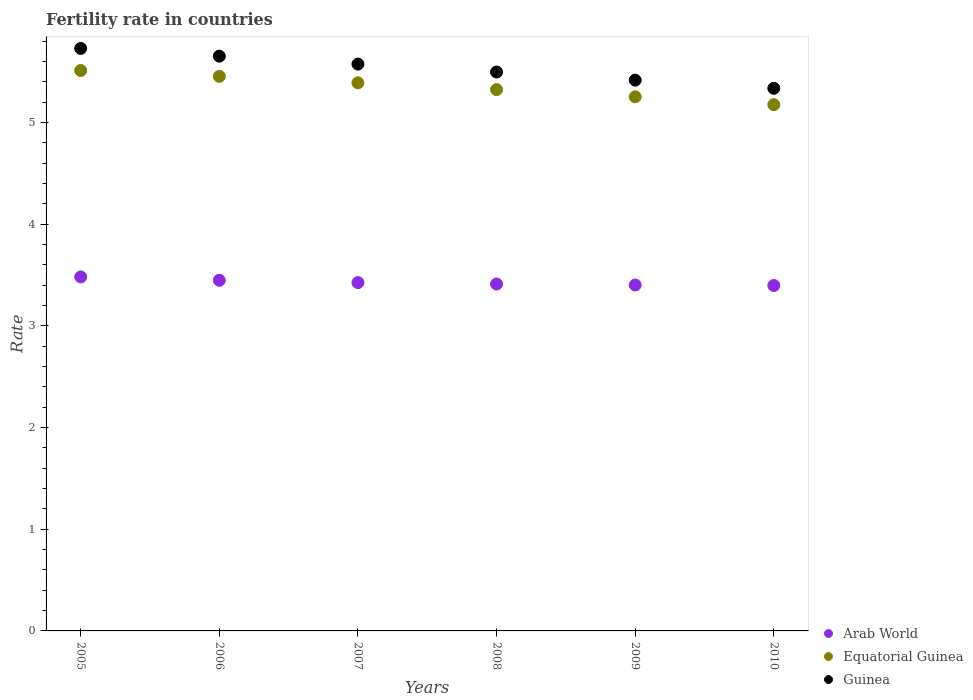What is the fertility rate in Guinea in 2006?
Ensure brevity in your answer.  5.65. Across all years, what is the maximum fertility rate in Equatorial Guinea?
Make the answer very short. 5.51. Across all years, what is the minimum fertility rate in Guinea?
Your answer should be compact. 5.34. In which year was the fertility rate in Guinea maximum?
Your answer should be very brief. 2005. What is the total fertility rate in Guinea in the graph?
Ensure brevity in your answer.  33.21. What is the difference between the fertility rate in Guinea in 2007 and that in 2010?
Give a very brief answer. 0.24. What is the difference between the fertility rate in Guinea in 2005 and the fertility rate in Arab World in 2007?
Your answer should be very brief. 2.3. What is the average fertility rate in Guinea per year?
Provide a short and direct response. 5.53. In the year 2010, what is the difference between the fertility rate in Arab World and fertility rate in Guinea?
Your answer should be compact. -1.94. In how many years, is the fertility rate in Guinea greater than 2.8?
Keep it short and to the point. 6. What is the ratio of the fertility rate in Equatorial Guinea in 2007 to that in 2010?
Provide a short and direct response. 1.04. What is the difference between the highest and the second highest fertility rate in Guinea?
Keep it short and to the point. 0.08. What is the difference between the highest and the lowest fertility rate in Guinea?
Your response must be concise. 0.39. Is the fertility rate in Equatorial Guinea strictly less than the fertility rate in Guinea over the years?
Offer a terse response. Yes. How many years are there in the graph?
Offer a very short reply. 6. What is the difference between two consecutive major ticks on the Y-axis?
Offer a terse response. 1. Does the graph contain any zero values?
Offer a terse response. No. Does the graph contain grids?
Provide a short and direct response. No. What is the title of the graph?
Keep it short and to the point. Fertility rate in countries. Does "Malta" appear as one of the legend labels in the graph?
Your response must be concise. No. What is the label or title of the Y-axis?
Provide a short and direct response. Rate. What is the Rate of Arab World in 2005?
Offer a terse response. 3.48. What is the Rate in Equatorial Guinea in 2005?
Provide a succinct answer. 5.51. What is the Rate in Guinea in 2005?
Your answer should be compact. 5.73. What is the Rate of Arab World in 2006?
Make the answer very short. 3.45. What is the Rate in Equatorial Guinea in 2006?
Offer a very short reply. 5.45. What is the Rate in Guinea in 2006?
Your answer should be compact. 5.65. What is the Rate of Arab World in 2007?
Keep it short and to the point. 3.43. What is the Rate of Equatorial Guinea in 2007?
Provide a succinct answer. 5.39. What is the Rate in Guinea in 2007?
Your answer should be very brief. 5.58. What is the Rate in Arab World in 2008?
Make the answer very short. 3.41. What is the Rate of Equatorial Guinea in 2008?
Ensure brevity in your answer.  5.32. What is the Rate of Guinea in 2008?
Offer a terse response. 5.5. What is the Rate of Arab World in 2009?
Your response must be concise. 3.4. What is the Rate in Equatorial Guinea in 2009?
Your answer should be very brief. 5.25. What is the Rate of Guinea in 2009?
Provide a succinct answer. 5.42. What is the Rate of Arab World in 2010?
Give a very brief answer. 3.4. What is the Rate of Equatorial Guinea in 2010?
Provide a short and direct response. 5.18. What is the Rate in Guinea in 2010?
Give a very brief answer. 5.34. Across all years, what is the maximum Rate of Arab World?
Offer a very short reply. 3.48. Across all years, what is the maximum Rate in Equatorial Guinea?
Give a very brief answer. 5.51. Across all years, what is the maximum Rate in Guinea?
Your answer should be compact. 5.73. Across all years, what is the minimum Rate in Arab World?
Offer a very short reply. 3.4. Across all years, what is the minimum Rate in Equatorial Guinea?
Keep it short and to the point. 5.18. Across all years, what is the minimum Rate of Guinea?
Your answer should be compact. 5.34. What is the total Rate in Arab World in the graph?
Your response must be concise. 20.57. What is the total Rate of Equatorial Guinea in the graph?
Your response must be concise. 32.11. What is the total Rate of Guinea in the graph?
Make the answer very short. 33.21. What is the difference between the Rate of Arab World in 2005 and that in 2006?
Give a very brief answer. 0.03. What is the difference between the Rate in Equatorial Guinea in 2005 and that in 2006?
Your answer should be very brief. 0.06. What is the difference between the Rate of Guinea in 2005 and that in 2006?
Ensure brevity in your answer.  0.08. What is the difference between the Rate of Arab World in 2005 and that in 2007?
Make the answer very short. 0.06. What is the difference between the Rate of Equatorial Guinea in 2005 and that in 2007?
Offer a terse response. 0.12. What is the difference between the Rate of Guinea in 2005 and that in 2007?
Your response must be concise. 0.15. What is the difference between the Rate in Arab World in 2005 and that in 2008?
Your answer should be very brief. 0.07. What is the difference between the Rate of Equatorial Guinea in 2005 and that in 2008?
Give a very brief answer. 0.19. What is the difference between the Rate in Guinea in 2005 and that in 2008?
Ensure brevity in your answer.  0.23. What is the difference between the Rate of Arab World in 2005 and that in 2009?
Keep it short and to the point. 0.08. What is the difference between the Rate in Equatorial Guinea in 2005 and that in 2009?
Offer a terse response. 0.26. What is the difference between the Rate in Guinea in 2005 and that in 2009?
Offer a very short reply. 0.31. What is the difference between the Rate of Arab World in 2005 and that in 2010?
Provide a short and direct response. 0.08. What is the difference between the Rate in Equatorial Guinea in 2005 and that in 2010?
Your response must be concise. 0.34. What is the difference between the Rate of Guinea in 2005 and that in 2010?
Your answer should be very brief. 0.39. What is the difference between the Rate of Arab World in 2006 and that in 2007?
Your response must be concise. 0.02. What is the difference between the Rate in Equatorial Guinea in 2006 and that in 2007?
Provide a short and direct response. 0.06. What is the difference between the Rate in Guinea in 2006 and that in 2007?
Provide a succinct answer. 0.08. What is the difference between the Rate in Arab World in 2006 and that in 2008?
Provide a succinct answer. 0.04. What is the difference between the Rate in Equatorial Guinea in 2006 and that in 2008?
Offer a very short reply. 0.13. What is the difference between the Rate of Guinea in 2006 and that in 2008?
Offer a terse response. 0.16. What is the difference between the Rate in Arab World in 2006 and that in 2009?
Provide a short and direct response. 0.05. What is the difference between the Rate of Equatorial Guinea in 2006 and that in 2009?
Provide a short and direct response. 0.2. What is the difference between the Rate in Guinea in 2006 and that in 2009?
Offer a terse response. 0.24. What is the difference between the Rate in Arab World in 2006 and that in 2010?
Ensure brevity in your answer.  0.05. What is the difference between the Rate of Equatorial Guinea in 2006 and that in 2010?
Keep it short and to the point. 0.28. What is the difference between the Rate in Guinea in 2006 and that in 2010?
Make the answer very short. 0.32. What is the difference between the Rate of Arab World in 2007 and that in 2008?
Provide a succinct answer. 0.01. What is the difference between the Rate of Equatorial Guinea in 2007 and that in 2008?
Make the answer very short. 0.07. What is the difference between the Rate in Guinea in 2007 and that in 2008?
Keep it short and to the point. 0.08. What is the difference between the Rate in Arab World in 2007 and that in 2009?
Make the answer very short. 0.02. What is the difference between the Rate of Equatorial Guinea in 2007 and that in 2009?
Your response must be concise. 0.14. What is the difference between the Rate of Guinea in 2007 and that in 2009?
Offer a terse response. 0.16. What is the difference between the Rate of Arab World in 2007 and that in 2010?
Your response must be concise. 0.03. What is the difference between the Rate in Equatorial Guinea in 2007 and that in 2010?
Provide a succinct answer. 0.21. What is the difference between the Rate in Guinea in 2007 and that in 2010?
Offer a very short reply. 0.24. What is the difference between the Rate of Arab World in 2008 and that in 2009?
Keep it short and to the point. 0.01. What is the difference between the Rate of Equatorial Guinea in 2008 and that in 2009?
Offer a very short reply. 0.07. What is the difference between the Rate of Arab World in 2008 and that in 2010?
Your answer should be very brief. 0.01. What is the difference between the Rate of Equatorial Guinea in 2008 and that in 2010?
Your answer should be compact. 0.15. What is the difference between the Rate of Guinea in 2008 and that in 2010?
Ensure brevity in your answer.  0.16. What is the difference between the Rate in Arab World in 2009 and that in 2010?
Provide a succinct answer. 0.01. What is the difference between the Rate of Equatorial Guinea in 2009 and that in 2010?
Make the answer very short. 0.08. What is the difference between the Rate of Guinea in 2009 and that in 2010?
Provide a short and direct response. 0.08. What is the difference between the Rate of Arab World in 2005 and the Rate of Equatorial Guinea in 2006?
Your answer should be very brief. -1.97. What is the difference between the Rate of Arab World in 2005 and the Rate of Guinea in 2006?
Keep it short and to the point. -2.17. What is the difference between the Rate in Equatorial Guinea in 2005 and the Rate in Guinea in 2006?
Provide a short and direct response. -0.14. What is the difference between the Rate of Arab World in 2005 and the Rate of Equatorial Guinea in 2007?
Provide a short and direct response. -1.91. What is the difference between the Rate of Arab World in 2005 and the Rate of Guinea in 2007?
Provide a short and direct response. -2.09. What is the difference between the Rate of Equatorial Guinea in 2005 and the Rate of Guinea in 2007?
Your answer should be compact. -0.06. What is the difference between the Rate of Arab World in 2005 and the Rate of Equatorial Guinea in 2008?
Your answer should be very brief. -1.84. What is the difference between the Rate in Arab World in 2005 and the Rate in Guinea in 2008?
Give a very brief answer. -2.02. What is the difference between the Rate of Equatorial Guinea in 2005 and the Rate of Guinea in 2008?
Keep it short and to the point. 0.01. What is the difference between the Rate in Arab World in 2005 and the Rate in Equatorial Guinea in 2009?
Your answer should be compact. -1.77. What is the difference between the Rate in Arab World in 2005 and the Rate in Guinea in 2009?
Keep it short and to the point. -1.94. What is the difference between the Rate of Equatorial Guinea in 2005 and the Rate of Guinea in 2009?
Your answer should be compact. 0.1. What is the difference between the Rate of Arab World in 2005 and the Rate of Equatorial Guinea in 2010?
Your answer should be very brief. -1.69. What is the difference between the Rate of Arab World in 2005 and the Rate of Guinea in 2010?
Give a very brief answer. -1.86. What is the difference between the Rate of Equatorial Guinea in 2005 and the Rate of Guinea in 2010?
Your answer should be very brief. 0.17. What is the difference between the Rate in Arab World in 2006 and the Rate in Equatorial Guinea in 2007?
Make the answer very short. -1.94. What is the difference between the Rate in Arab World in 2006 and the Rate in Guinea in 2007?
Provide a short and direct response. -2.13. What is the difference between the Rate of Equatorial Guinea in 2006 and the Rate of Guinea in 2007?
Give a very brief answer. -0.12. What is the difference between the Rate in Arab World in 2006 and the Rate in Equatorial Guinea in 2008?
Give a very brief answer. -1.88. What is the difference between the Rate of Arab World in 2006 and the Rate of Guinea in 2008?
Provide a succinct answer. -2.05. What is the difference between the Rate in Equatorial Guinea in 2006 and the Rate in Guinea in 2008?
Provide a succinct answer. -0.04. What is the difference between the Rate in Arab World in 2006 and the Rate in Equatorial Guinea in 2009?
Your answer should be compact. -1.8. What is the difference between the Rate of Arab World in 2006 and the Rate of Guinea in 2009?
Ensure brevity in your answer.  -1.97. What is the difference between the Rate in Equatorial Guinea in 2006 and the Rate in Guinea in 2009?
Keep it short and to the point. 0.04. What is the difference between the Rate of Arab World in 2006 and the Rate of Equatorial Guinea in 2010?
Make the answer very short. -1.73. What is the difference between the Rate of Arab World in 2006 and the Rate of Guinea in 2010?
Ensure brevity in your answer.  -1.89. What is the difference between the Rate of Equatorial Guinea in 2006 and the Rate of Guinea in 2010?
Provide a short and direct response. 0.12. What is the difference between the Rate in Arab World in 2007 and the Rate in Equatorial Guinea in 2008?
Keep it short and to the point. -1.9. What is the difference between the Rate in Arab World in 2007 and the Rate in Guinea in 2008?
Make the answer very short. -2.07. What is the difference between the Rate of Equatorial Guinea in 2007 and the Rate of Guinea in 2008?
Make the answer very short. -0.11. What is the difference between the Rate in Arab World in 2007 and the Rate in Equatorial Guinea in 2009?
Ensure brevity in your answer.  -1.83. What is the difference between the Rate of Arab World in 2007 and the Rate of Guinea in 2009?
Make the answer very short. -1.99. What is the difference between the Rate of Equatorial Guinea in 2007 and the Rate of Guinea in 2009?
Keep it short and to the point. -0.03. What is the difference between the Rate in Arab World in 2007 and the Rate in Equatorial Guinea in 2010?
Your response must be concise. -1.75. What is the difference between the Rate in Arab World in 2007 and the Rate in Guinea in 2010?
Ensure brevity in your answer.  -1.91. What is the difference between the Rate in Equatorial Guinea in 2007 and the Rate in Guinea in 2010?
Keep it short and to the point. 0.05. What is the difference between the Rate in Arab World in 2008 and the Rate in Equatorial Guinea in 2009?
Provide a short and direct response. -1.84. What is the difference between the Rate of Arab World in 2008 and the Rate of Guinea in 2009?
Offer a terse response. -2. What is the difference between the Rate in Equatorial Guinea in 2008 and the Rate in Guinea in 2009?
Your response must be concise. -0.09. What is the difference between the Rate in Arab World in 2008 and the Rate in Equatorial Guinea in 2010?
Provide a short and direct response. -1.76. What is the difference between the Rate in Arab World in 2008 and the Rate in Guinea in 2010?
Your answer should be compact. -1.93. What is the difference between the Rate of Equatorial Guinea in 2008 and the Rate of Guinea in 2010?
Make the answer very short. -0.01. What is the difference between the Rate of Arab World in 2009 and the Rate of Equatorial Guinea in 2010?
Your answer should be compact. -1.77. What is the difference between the Rate in Arab World in 2009 and the Rate in Guinea in 2010?
Provide a short and direct response. -1.93. What is the difference between the Rate of Equatorial Guinea in 2009 and the Rate of Guinea in 2010?
Give a very brief answer. -0.08. What is the average Rate in Arab World per year?
Ensure brevity in your answer.  3.43. What is the average Rate in Equatorial Guinea per year?
Make the answer very short. 5.35. What is the average Rate in Guinea per year?
Offer a very short reply. 5.53. In the year 2005, what is the difference between the Rate in Arab World and Rate in Equatorial Guinea?
Provide a succinct answer. -2.03. In the year 2005, what is the difference between the Rate of Arab World and Rate of Guinea?
Offer a terse response. -2.25. In the year 2005, what is the difference between the Rate of Equatorial Guinea and Rate of Guinea?
Offer a very short reply. -0.22. In the year 2006, what is the difference between the Rate of Arab World and Rate of Equatorial Guinea?
Provide a short and direct response. -2.01. In the year 2006, what is the difference between the Rate of Arab World and Rate of Guinea?
Your response must be concise. -2.2. In the year 2006, what is the difference between the Rate of Equatorial Guinea and Rate of Guinea?
Ensure brevity in your answer.  -0.2. In the year 2007, what is the difference between the Rate in Arab World and Rate in Equatorial Guinea?
Ensure brevity in your answer.  -1.97. In the year 2007, what is the difference between the Rate of Arab World and Rate of Guinea?
Ensure brevity in your answer.  -2.15. In the year 2007, what is the difference between the Rate of Equatorial Guinea and Rate of Guinea?
Make the answer very short. -0.18. In the year 2008, what is the difference between the Rate of Arab World and Rate of Equatorial Guinea?
Give a very brief answer. -1.91. In the year 2008, what is the difference between the Rate of Arab World and Rate of Guinea?
Provide a succinct answer. -2.08. In the year 2008, what is the difference between the Rate of Equatorial Guinea and Rate of Guinea?
Keep it short and to the point. -0.17. In the year 2009, what is the difference between the Rate in Arab World and Rate in Equatorial Guinea?
Make the answer very short. -1.85. In the year 2009, what is the difference between the Rate in Arab World and Rate in Guinea?
Offer a very short reply. -2.01. In the year 2009, what is the difference between the Rate of Equatorial Guinea and Rate of Guinea?
Keep it short and to the point. -0.16. In the year 2010, what is the difference between the Rate of Arab World and Rate of Equatorial Guinea?
Provide a succinct answer. -1.78. In the year 2010, what is the difference between the Rate of Arab World and Rate of Guinea?
Your answer should be very brief. -1.94. In the year 2010, what is the difference between the Rate of Equatorial Guinea and Rate of Guinea?
Your response must be concise. -0.16. What is the ratio of the Rate in Arab World in 2005 to that in 2006?
Provide a short and direct response. 1.01. What is the ratio of the Rate of Equatorial Guinea in 2005 to that in 2006?
Your answer should be compact. 1.01. What is the ratio of the Rate in Guinea in 2005 to that in 2006?
Offer a very short reply. 1.01. What is the ratio of the Rate of Arab World in 2005 to that in 2007?
Your answer should be compact. 1.02. What is the ratio of the Rate of Equatorial Guinea in 2005 to that in 2007?
Your response must be concise. 1.02. What is the ratio of the Rate of Guinea in 2005 to that in 2007?
Offer a terse response. 1.03. What is the ratio of the Rate in Arab World in 2005 to that in 2008?
Your response must be concise. 1.02. What is the ratio of the Rate in Equatorial Guinea in 2005 to that in 2008?
Keep it short and to the point. 1.04. What is the ratio of the Rate in Guinea in 2005 to that in 2008?
Your answer should be very brief. 1.04. What is the ratio of the Rate in Arab World in 2005 to that in 2009?
Your response must be concise. 1.02. What is the ratio of the Rate of Equatorial Guinea in 2005 to that in 2009?
Provide a short and direct response. 1.05. What is the ratio of the Rate of Guinea in 2005 to that in 2009?
Give a very brief answer. 1.06. What is the ratio of the Rate in Arab World in 2005 to that in 2010?
Offer a very short reply. 1.02. What is the ratio of the Rate in Equatorial Guinea in 2005 to that in 2010?
Your response must be concise. 1.06. What is the ratio of the Rate of Guinea in 2005 to that in 2010?
Provide a succinct answer. 1.07. What is the ratio of the Rate in Arab World in 2006 to that in 2007?
Provide a short and direct response. 1.01. What is the ratio of the Rate in Equatorial Guinea in 2006 to that in 2007?
Give a very brief answer. 1.01. What is the ratio of the Rate in Guinea in 2006 to that in 2007?
Your answer should be compact. 1.01. What is the ratio of the Rate in Arab World in 2006 to that in 2008?
Your answer should be compact. 1.01. What is the ratio of the Rate in Equatorial Guinea in 2006 to that in 2008?
Give a very brief answer. 1.02. What is the ratio of the Rate of Guinea in 2006 to that in 2008?
Your answer should be very brief. 1.03. What is the ratio of the Rate of Arab World in 2006 to that in 2009?
Keep it short and to the point. 1.01. What is the ratio of the Rate of Equatorial Guinea in 2006 to that in 2009?
Make the answer very short. 1.04. What is the ratio of the Rate in Guinea in 2006 to that in 2009?
Keep it short and to the point. 1.04. What is the ratio of the Rate of Arab World in 2006 to that in 2010?
Offer a terse response. 1.02. What is the ratio of the Rate in Equatorial Guinea in 2006 to that in 2010?
Offer a terse response. 1.05. What is the ratio of the Rate in Guinea in 2006 to that in 2010?
Give a very brief answer. 1.06. What is the ratio of the Rate in Arab World in 2007 to that in 2008?
Provide a succinct answer. 1. What is the ratio of the Rate in Equatorial Guinea in 2007 to that in 2008?
Your response must be concise. 1.01. What is the ratio of the Rate in Guinea in 2007 to that in 2008?
Provide a short and direct response. 1.01. What is the ratio of the Rate in Equatorial Guinea in 2007 to that in 2009?
Ensure brevity in your answer.  1.03. What is the ratio of the Rate of Guinea in 2007 to that in 2009?
Your answer should be very brief. 1.03. What is the ratio of the Rate in Arab World in 2007 to that in 2010?
Your answer should be very brief. 1.01. What is the ratio of the Rate in Equatorial Guinea in 2007 to that in 2010?
Keep it short and to the point. 1.04. What is the ratio of the Rate in Guinea in 2007 to that in 2010?
Ensure brevity in your answer.  1.04. What is the ratio of the Rate in Equatorial Guinea in 2008 to that in 2009?
Keep it short and to the point. 1.01. What is the ratio of the Rate of Guinea in 2008 to that in 2009?
Your answer should be compact. 1.01. What is the ratio of the Rate in Equatorial Guinea in 2008 to that in 2010?
Offer a terse response. 1.03. What is the ratio of the Rate of Equatorial Guinea in 2009 to that in 2010?
Ensure brevity in your answer.  1.01. What is the difference between the highest and the second highest Rate of Arab World?
Provide a short and direct response. 0.03. What is the difference between the highest and the second highest Rate of Equatorial Guinea?
Give a very brief answer. 0.06. What is the difference between the highest and the second highest Rate of Guinea?
Give a very brief answer. 0.08. What is the difference between the highest and the lowest Rate of Arab World?
Your response must be concise. 0.08. What is the difference between the highest and the lowest Rate of Equatorial Guinea?
Your answer should be very brief. 0.34. What is the difference between the highest and the lowest Rate in Guinea?
Provide a succinct answer. 0.39. 